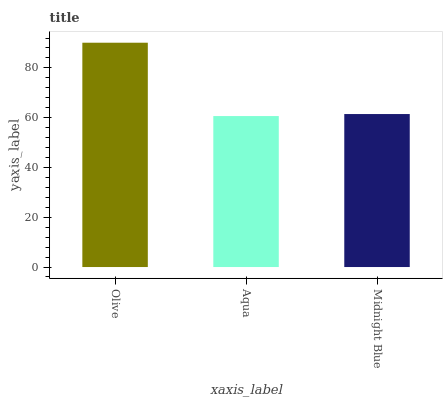Is Aqua the minimum?
Answer yes or no. Yes. Is Olive the maximum?
Answer yes or no. Yes. Is Midnight Blue the minimum?
Answer yes or no. No. Is Midnight Blue the maximum?
Answer yes or no. No. Is Midnight Blue greater than Aqua?
Answer yes or no. Yes. Is Aqua less than Midnight Blue?
Answer yes or no. Yes. Is Aqua greater than Midnight Blue?
Answer yes or no. No. Is Midnight Blue less than Aqua?
Answer yes or no. No. Is Midnight Blue the high median?
Answer yes or no. Yes. Is Midnight Blue the low median?
Answer yes or no. Yes. Is Aqua the high median?
Answer yes or no. No. Is Olive the low median?
Answer yes or no. No. 